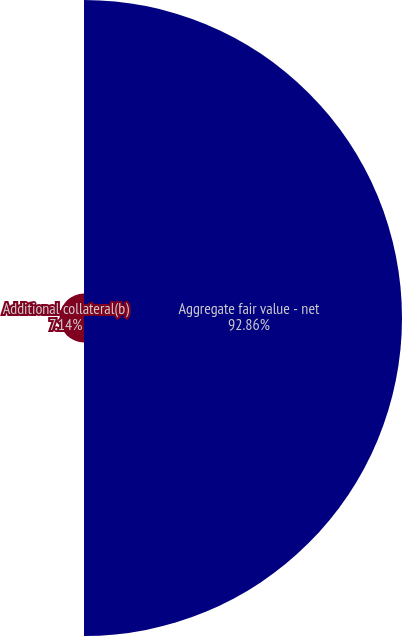<chart> <loc_0><loc_0><loc_500><loc_500><pie_chart><fcel>Aggregate fair value - net<fcel>Additional collateral(b)<nl><fcel>92.86%<fcel>7.14%<nl></chart> 